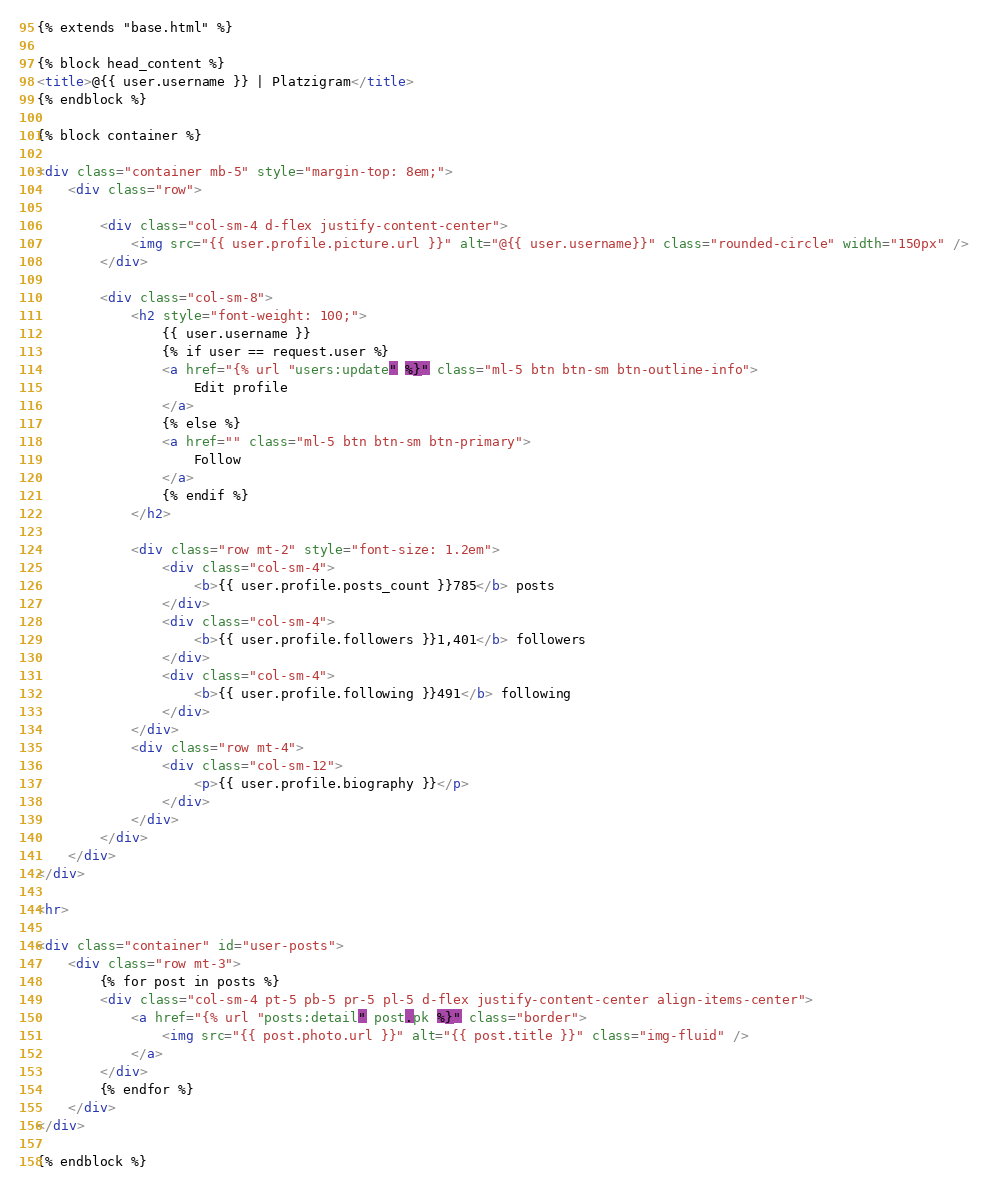<code> <loc_0><loc_0><loc_500><loc_500><_HTML_>{% extends "base.html" %}

{% block head_content %}
<title>@{{ user.username }} | Platzigram</title>
{% endblock %}

{% block container %}

<div class="container mb-5" style="margin-top: 8em;">
    <div class="row">

        <div class="col-sm-4 d-flex justify-content-center">
            <img src="{{ user.profile.picture.url }}" alt="@{{ user.username}}" class="rounded-circle" width="150px" />
        </div>

        <div class="col-sm-8">
            <h2 style="font-weight: 100;">
                {{ user.username }}
                {% if user == request.user %}
                <a href="{% url "users:update" %}" class="ml-5 btn btn-sm btn-outline-info">
                    Edit profile
                </a>
                {% else %}
                <a href="" class="ml-5 btn btn-sm btn-primary">
                    Follow
                </a>
                {% endif %}
            </h2>

            <div class="row mt-2" style="font-size: 1.2em">
                <div class="col-sm-4">
                    <b>{{ user.profile.posts_count }}785</b> posts
                </div>
                <div class="col-sm-4">
                    <b>{{ user.profile.followers }}1,401</b> followers
                </div>
                <div class="col-sm-4">
                    <b>{{ user.profile.following }}491</b> following
                </div>
            </div>
            <div class="row mt-4">
                <div class="col-sm-12">
                    <p>{{ user.profile.biography }}</p>
                </div>
            </div>
        </div>
    </div>
</div>

<hr>

<div class="container" id="user-posts">
    <div class="row mt-3">
        {% for post in posts %}
        <div class="col-sm-4 pt-5 pb-5 pr-5 pl-5 d-flex justify-content-center align-items-center">
            <a href="{% url "posts:detail" post.pk %}" class="border">
                <img src="{{ post.photo.url }}" alt="{{ post.title }}" class="img-fluid" />
            </a>
        </div>
        {% endfor %}
    </div>
</div>

{% endblock %}</code> 